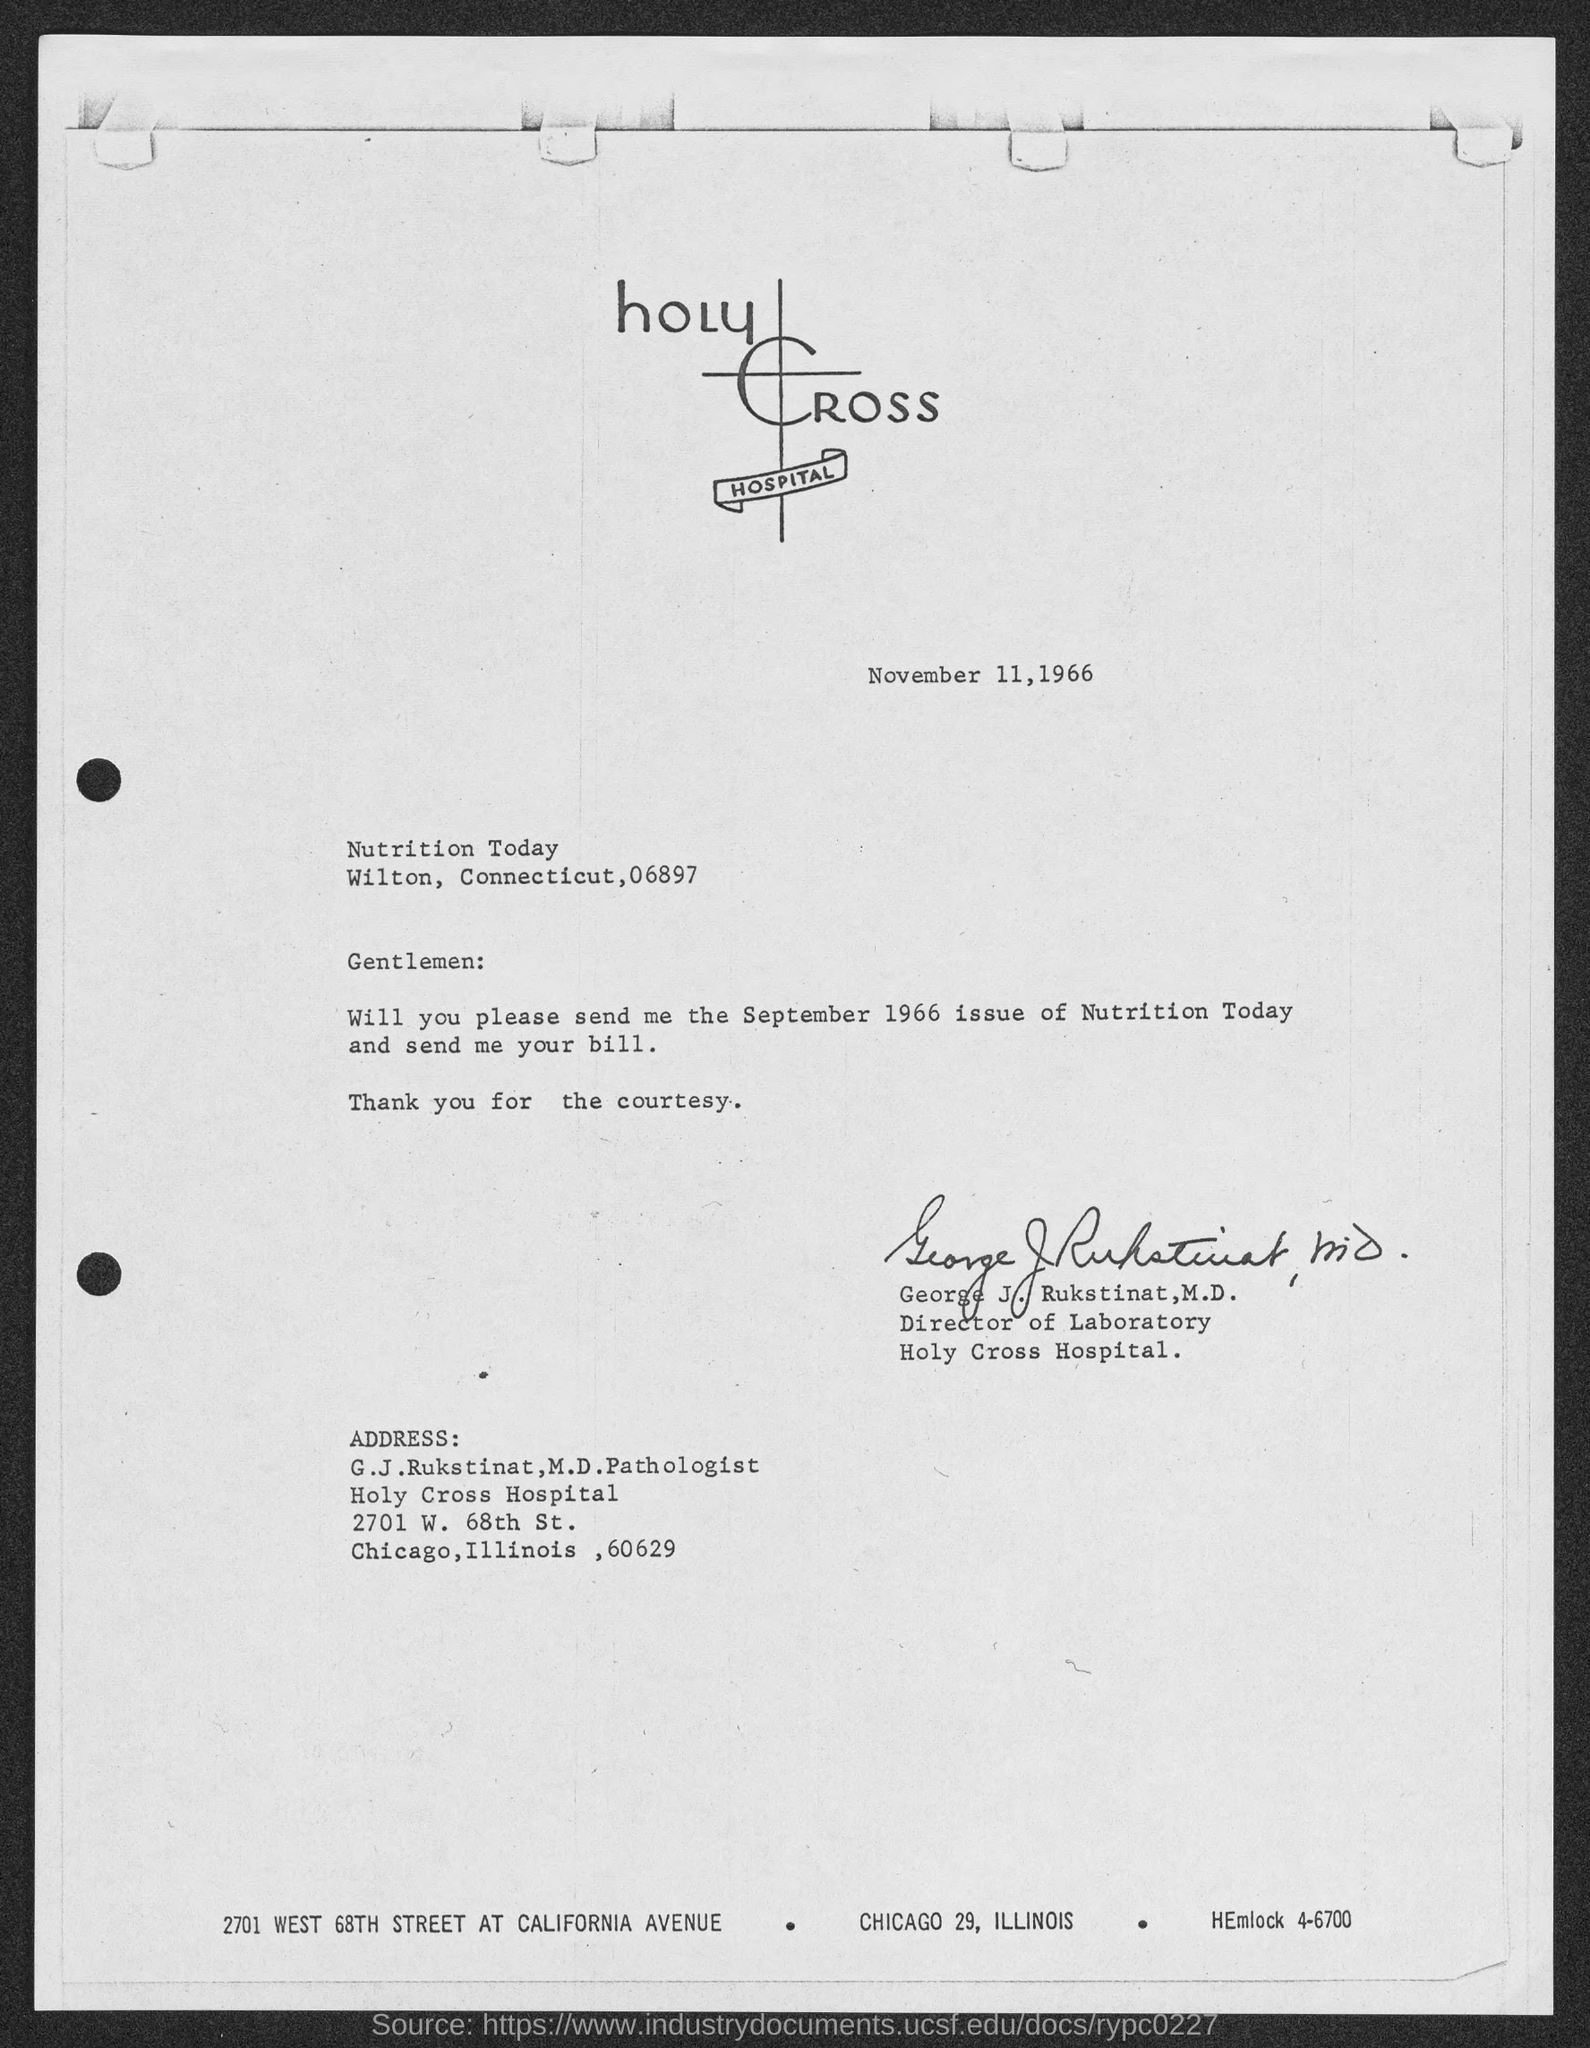Specify some key components in this picture. The date mentioned at the top of the document is November 11, 1966. 